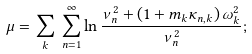Convert formula to latex. <formula><loc_0><loc_0><loc_500><loc_500>\mu = \sum _ { k } \, \sum _ { n = 1 } ^ { \infty } \ln \frac { \nu _ { n } ^ { 2 } + ( 1 + m _ { k } \kappa _ { n , k } ) \, \omega ^ { 2 } _ { k } } { \nu _ { n } ^ { 2 } } ;</formula> 